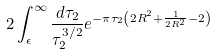Convert formula to latex. <formula><loc_0><loc_0><loc_500><loc_500>2 \int _ { \epsilon } ^ { \infty } \frac { d \tau _ { 2 } } { \tau _ { 2 } ^ { 3 / 2 } } e ^ { - \pi \tau _ { 2 } \left ( 2 R ^ { 2 } + \frac { 1 } { 2 R ^ { 2 } } - 2 \right ) }</formula> 